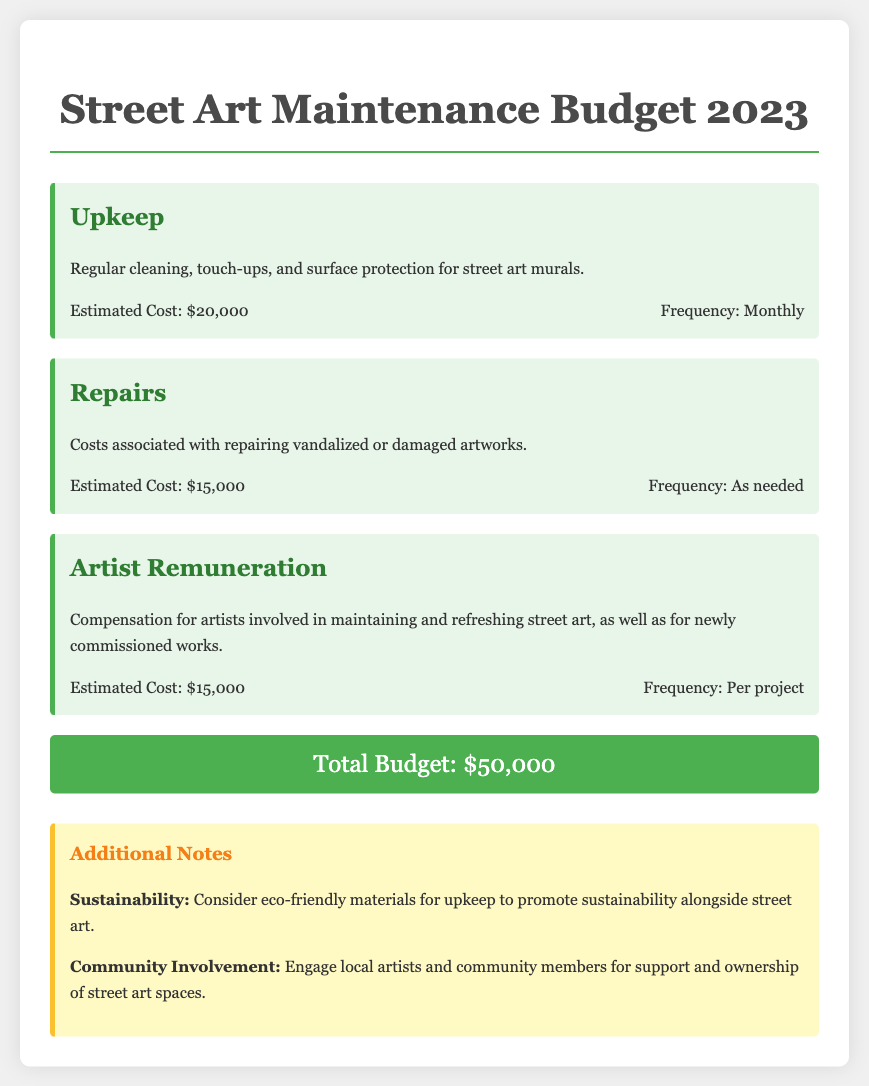What is the estimated cost for upkeep? The document states that the estimated cost for upkeep is $20,000.
Answer: $20,000 What is the total budget for street art maintenance? The total budget is explicitly mentioned in the document as $50,000.
Answer: $50,000 How often is upkeep performed? According to the document, upkeep is performed monthly.
Answer: Monthly What is the estimated cost for repairs? The document specifies that the estimated cost for repairs is $15,000.
Answer: $15,000 What is the frequency of artist remuneration? The document indicates that artist remuneration is compensated per project.
Answer: Per project What additional note suggests a focus on sustainability? The document mentions the use of eco-friendly materials for upkeep to promote sustainability.
Answer: Sustainability How much funding is allocated for artist remuneration? The document states that the budget allocated for artist remuneration is $15,000.
Answer: $15,000 What kind of community involvement is suggested in the notes? The document suggests engaging local artists and community members for support.
Answer: Support What is mentioned as a reason for repairs? The document notes that repairs are for vandalized or damaged artworks.
Answer: Damaged artworks 